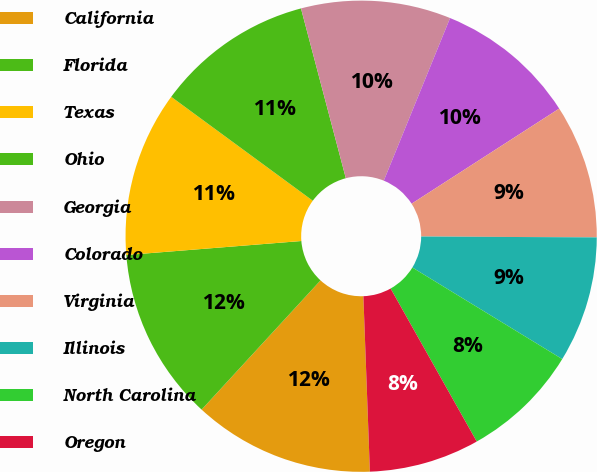Convert chart. <chart><loc_0><loc_0><loc_500><loc_500><pie_chart><fcel>California<fcel>Florida<fcel>Texas<fcel>Ohio<fcel>Georgia<fcel>Colorado<fcel>Virginia<fcel>Illinois<fcel>North Carolina<fcel>Oregon<nl><fcel>12.43%<fcel>11.89%<fcel>11.35%<fcel>10.81%<fcel>10.27%<fcel>9.73%<fcel>9.19%<fcel>8.65%<fcel>8.11%<fcel>7.57%<nl></chart> 